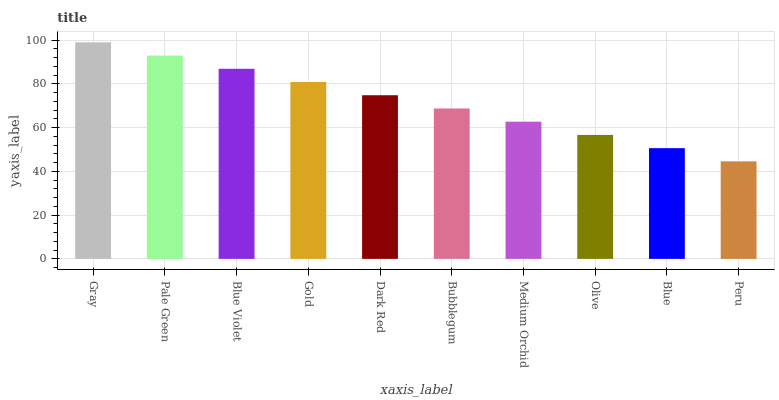Is Peru the minimum?
Answer yes or no. Yes. Is Gray the maximum?
Answer yes or no. Yes. Is Pale Green the minimum?
Answer yes or no. No. Is Pale Green the maximum?
Answer yes or no. No. Is Gray greater than Pale Green?
Answer yes or no. Yes. Is Pale Green less than Gray?
Answer yes or no. Yes. Is Pale Green greater than Gray?
Answer yes or no. No. Is Gray less than Pale Green?
Answer yes or no. No. Is Dark Red the high median?
Answer yes or no. Yes. Is Bubblegum the low median?
Answer yes or no. Yes. Is Medium Orchid the high median?
Answer yes or no. No. Is Olive the low median?
Answer yes or no. No. 